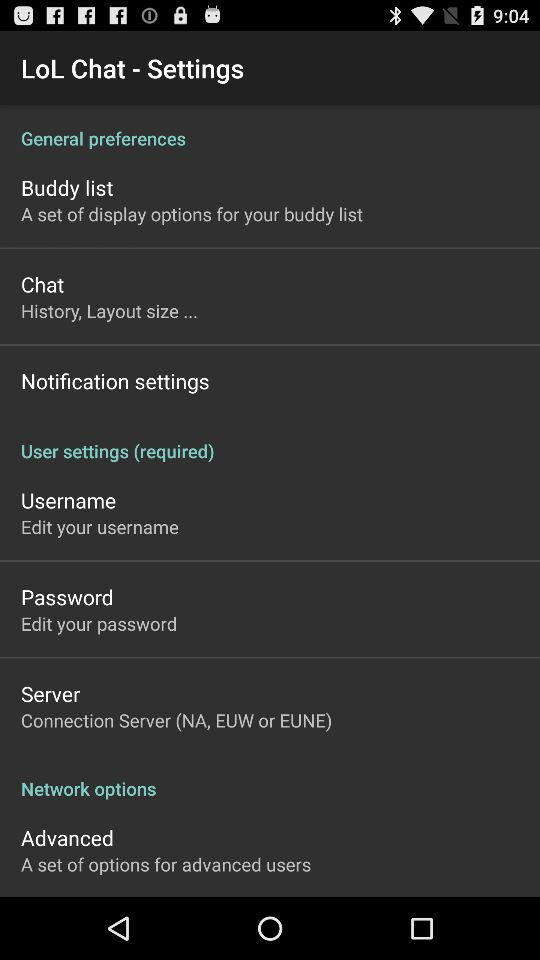What server is mentioned? The mentioned server is "Connection Server (NA, EUW or EUNE)". 